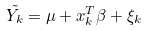<formula> <loc_0><loc_0><loc_500><loc_500>\tilde { Y _ { k } } = \mu + x _ { k } ^ { T } \beta + \xi _ { k }</formula> 